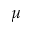Convert formula to latex. <formula><loc_0><loc_0><loc_500><loc_500>\mu</formula> 